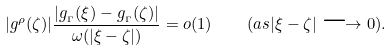Convert formula to latex. <formula><loc_0><loc_0><loc_500><loc_500>| g ^ { \rho } ( \zeta ) | \frac { | g _ { _ { \Gamma } } ( \xi ) - g _ { _ { \Gamma } } ( \zeta ) | } { \omega ( | \xi - \zeta | ) } = o ( 1 ) \quad ( a s | \xi - \zeta | \longrightarrow 0 ) .</formula> 